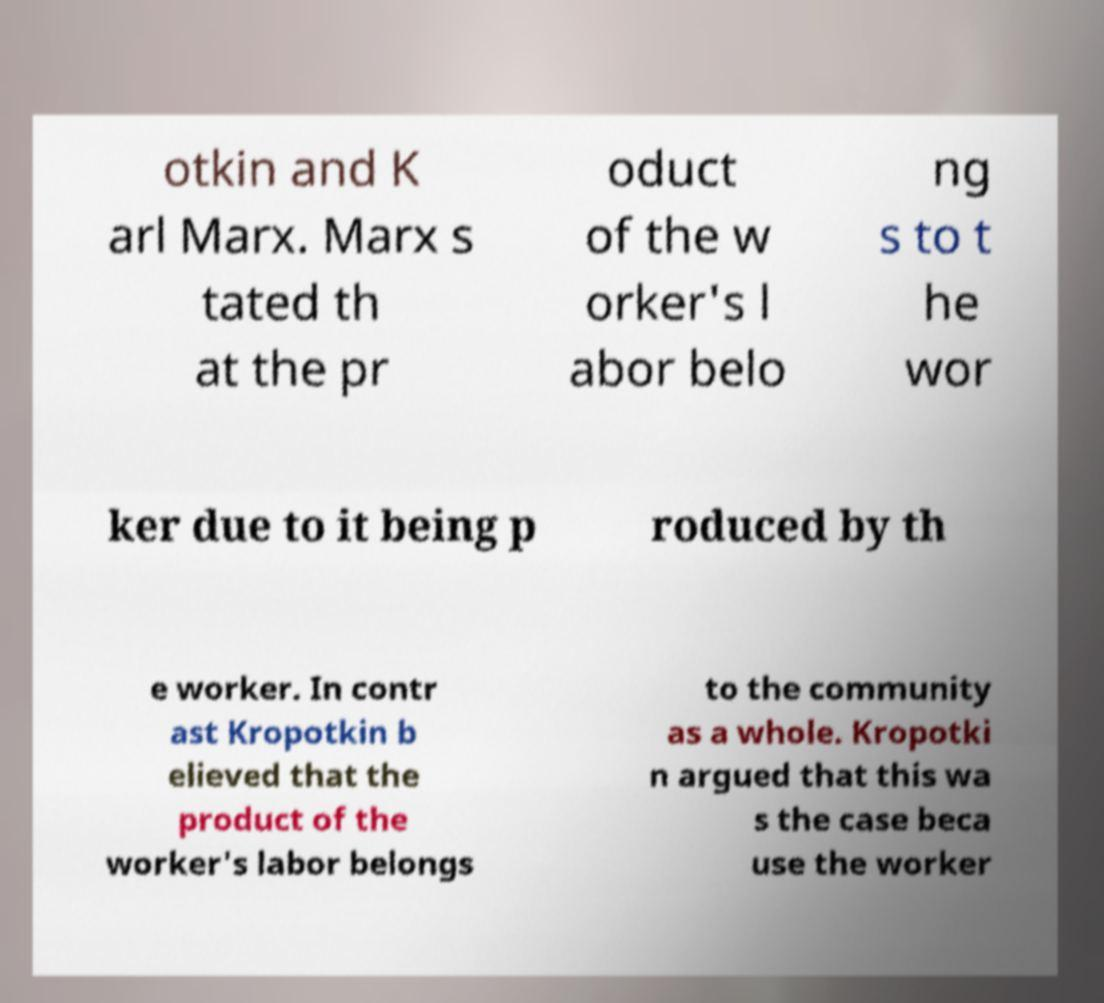Please identify and transcribe the text found in this image. otkin and K arl Marx. Marx s tated th at the pr oduct of the w orker's l abor belo ng s to t he wor ker due to it being p roduced by th e worker. In contr ast Kropotkin b elieved that the product of the worker's labor belongs to the community as a whole. Kropotki n argued that this wa s the case beca use the worker 